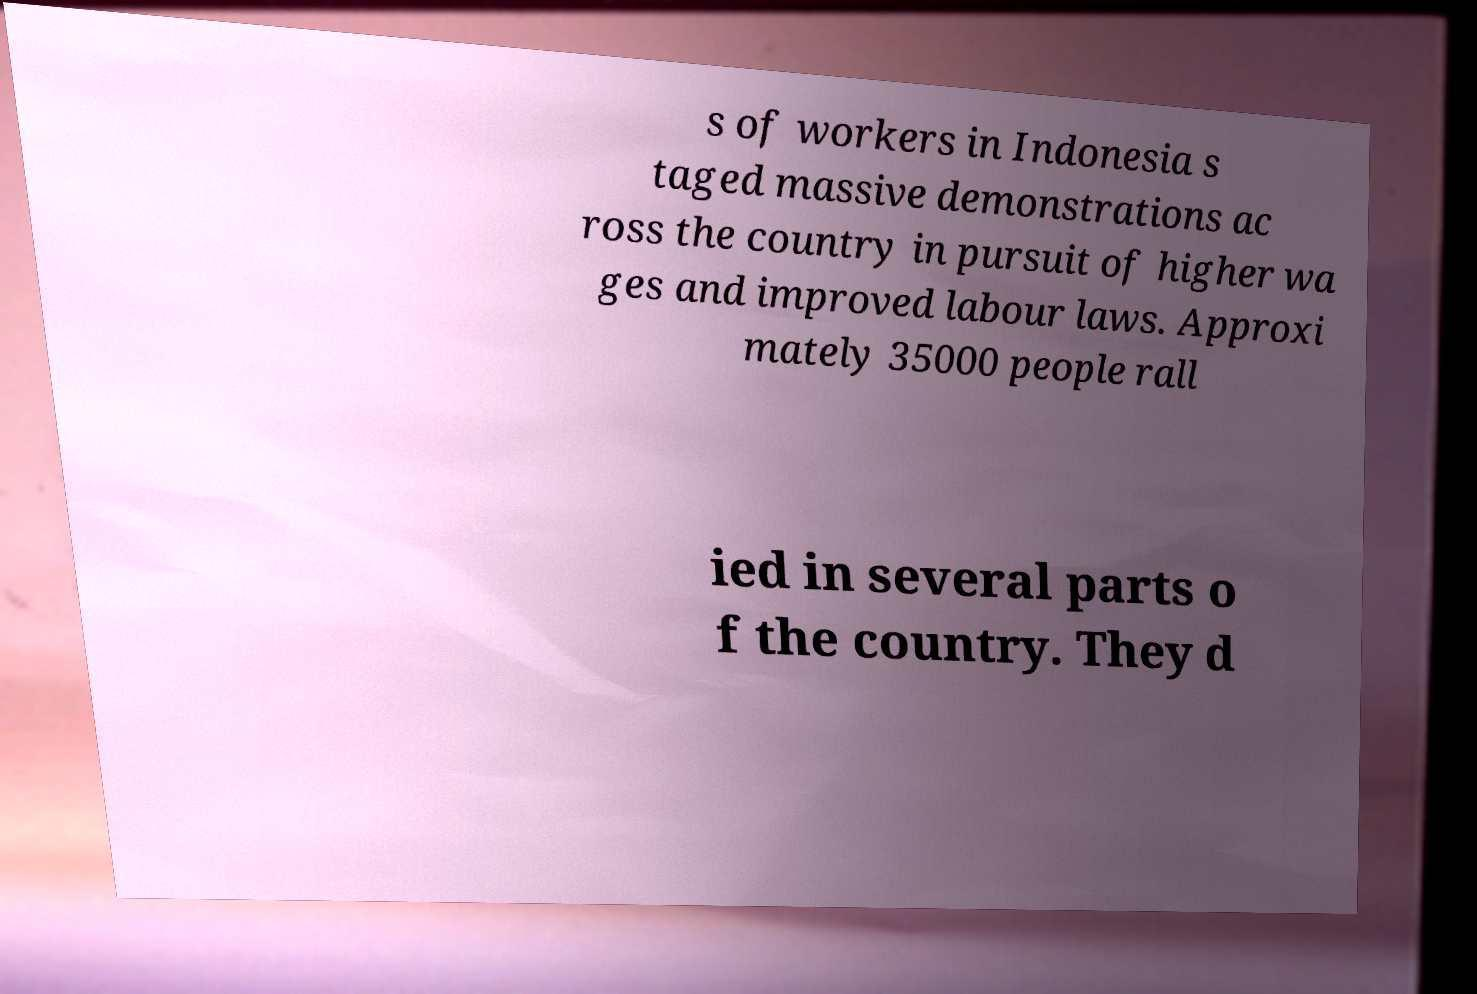Could you extract and type out the text from this image? s of workers in Indonesia s taged massive demonstrations ac ross the country in pursuit of higher wa ges and improved labour laws. Approxi mately 35000 people rall ied in several parts o f the country. They d 